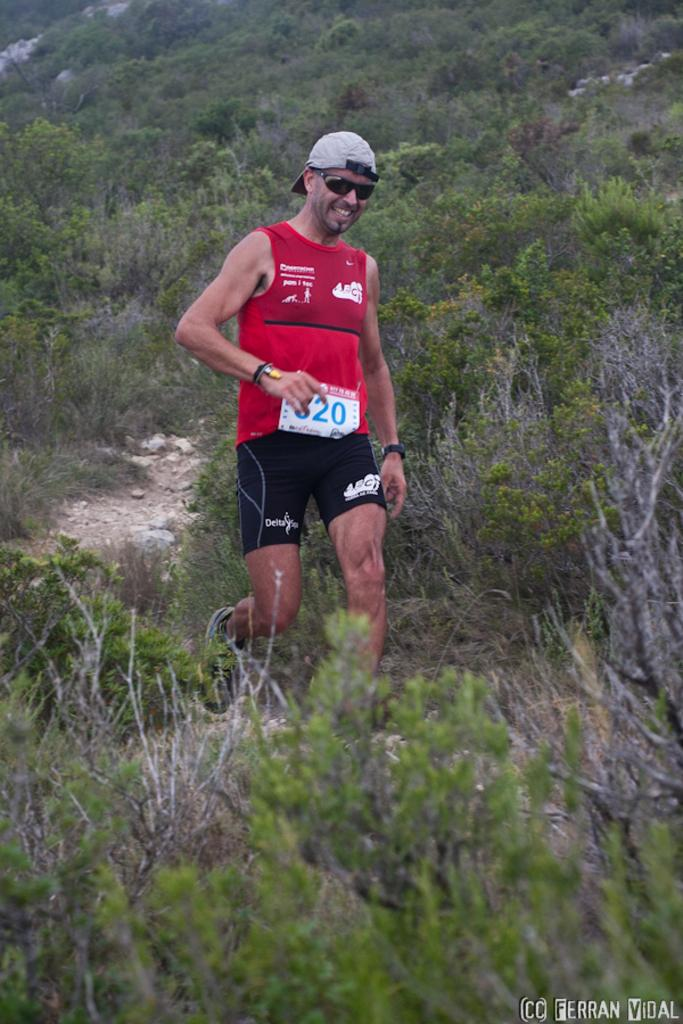Who is present in the picture? There is a man in the picture. What is the man wearing on his head? The man is wearing a cap. What is the man wearing to protect his eyes? The man is wearing goggles. What is the man doing in the picture? The man is walking. What can be seen in the background of the picture? The remaining portion of the picture is full of greenery. What type of surface is visible in the image? There are stones visible in the image. How many children are playing with the cushion in the image? There are no children or cushions present in the image. 